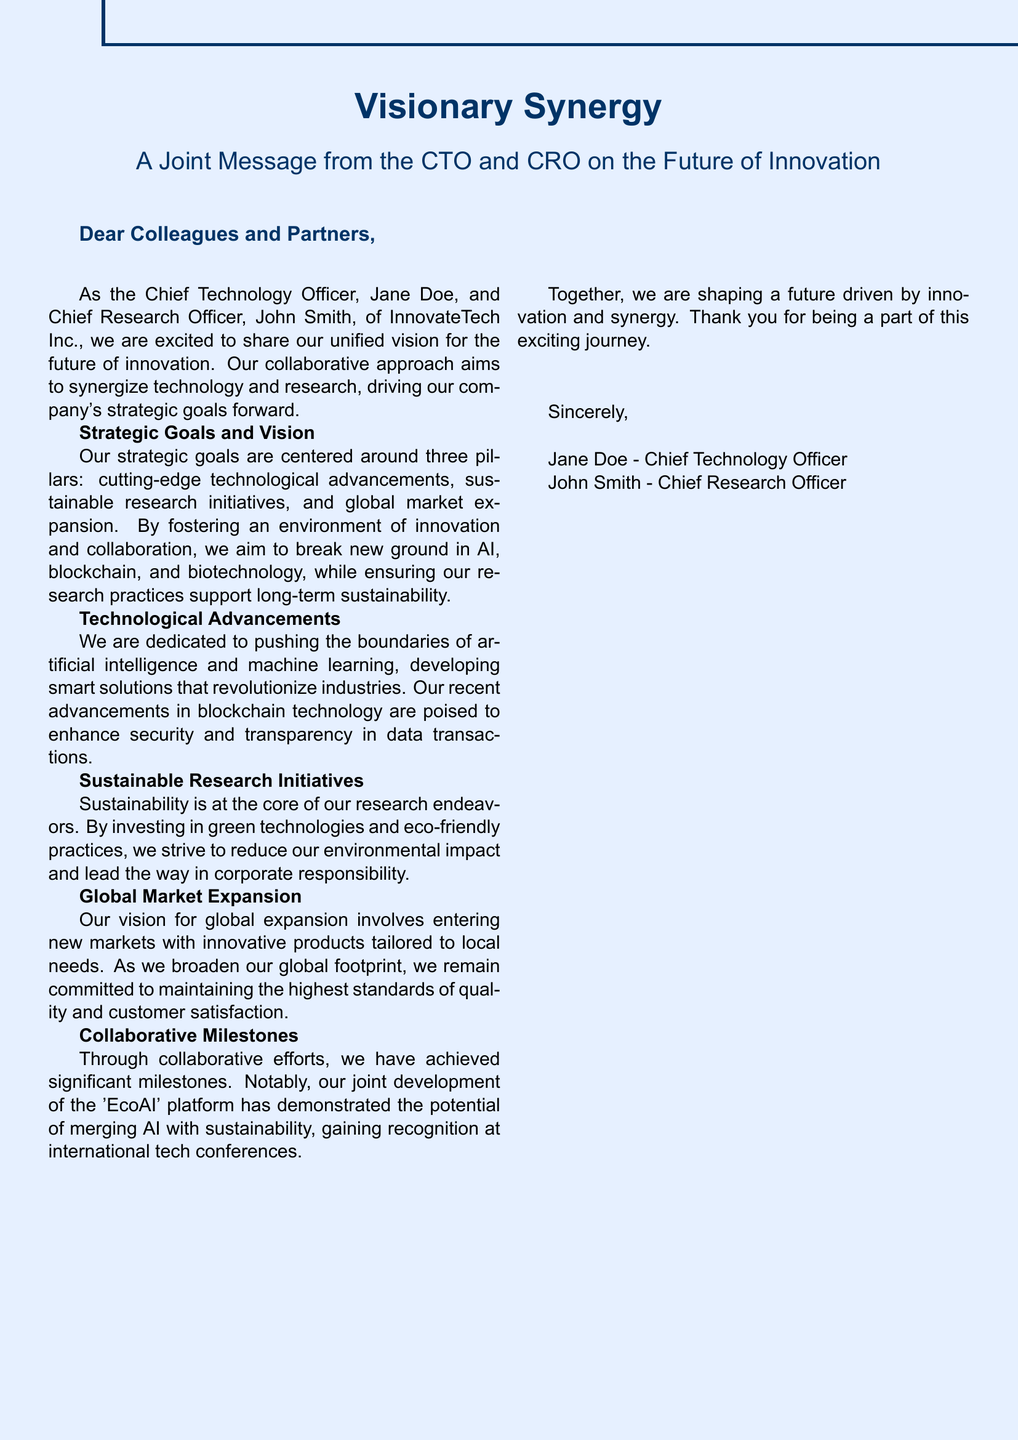What are the names of the authors? The document is authored by the Chief Technology Officer, Jane Doe, and the Chief Research Officer, John Smith.
Answer: Jane Doe, John Smith What is the main theme of the message? The main theme focuses on the unified vision for the future of innovation through synergy between technology and research.
Answer: Future of innovation What are the three pillars of strategic goals? The document states that the strategic goals are centered around technological advancements, sustainable research initiatives, and global market expansion.
Answer: Technological advancements, sustainable research initiatives, global market expansion Which platform was jointly developed? The document mentions the 'EcoAI' platform, highlighting its significance in merging AI with sustainability.
Answer: EcoAI What does sustainability in research aim to reduce? The document mentions that the aim of sustainability in research is to reduce environmental impact.
Answer: Environmental impact Who is the Chief Technology Officer? The document identifies Jane Doe as the Chief Technology Officer of InnovateTech Inc.
Answer: Jane Doe What type of innovations is the company focusing on? The document highlights that the company is focusing on innovations in AI, blockchain, and biotechnology.
Answer: AI, blockchain, and biotechnology How is the message structured? The document is structured as a greeting card with a joint message from the CTO and CRO detailing their vision and goals.
Answer: Greeting card 